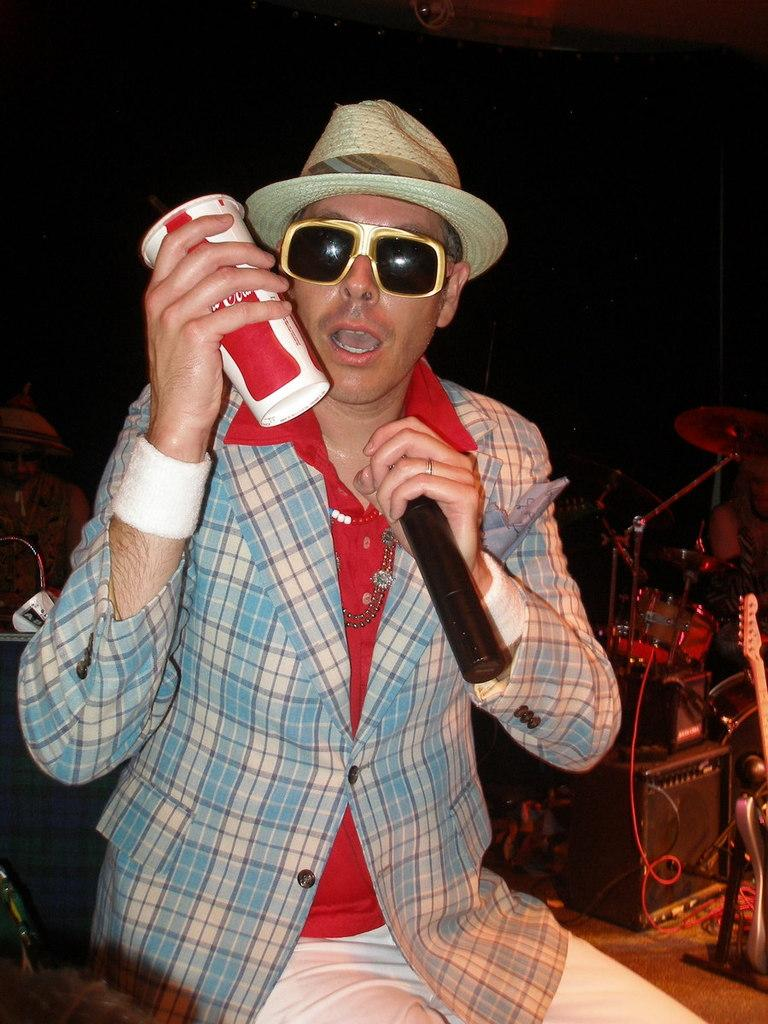What is the person in the image doing? The person is sitting in the image and holding a cup and a microphone. What might the person be using the microphone for? The person might be using the microphone for speaking or singing. What other objects are present in the image? There are musical instruments in the image. What is the color of the background in the image? The background of the image is black. Where is the quince placed on the shelf in the image? There is no quince or shelf present in the image. What type of cabbage can be seen growing in the background of the image? There is no cabbage visible in the image, and the background is black. 